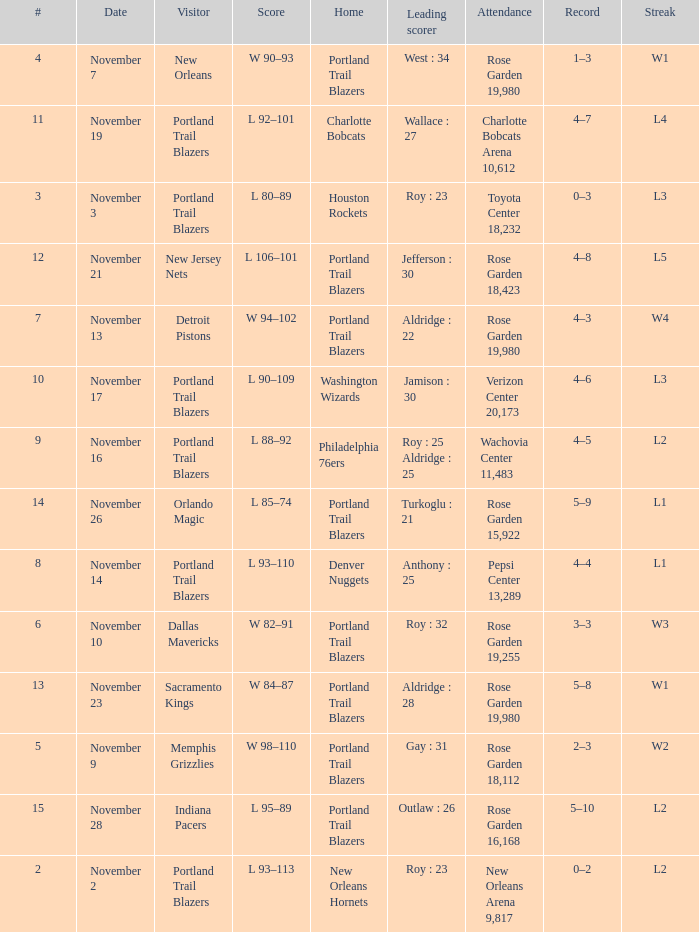 what's the home team where streak is l3 and leading scorer is roy : 23 Houston Rockets. 